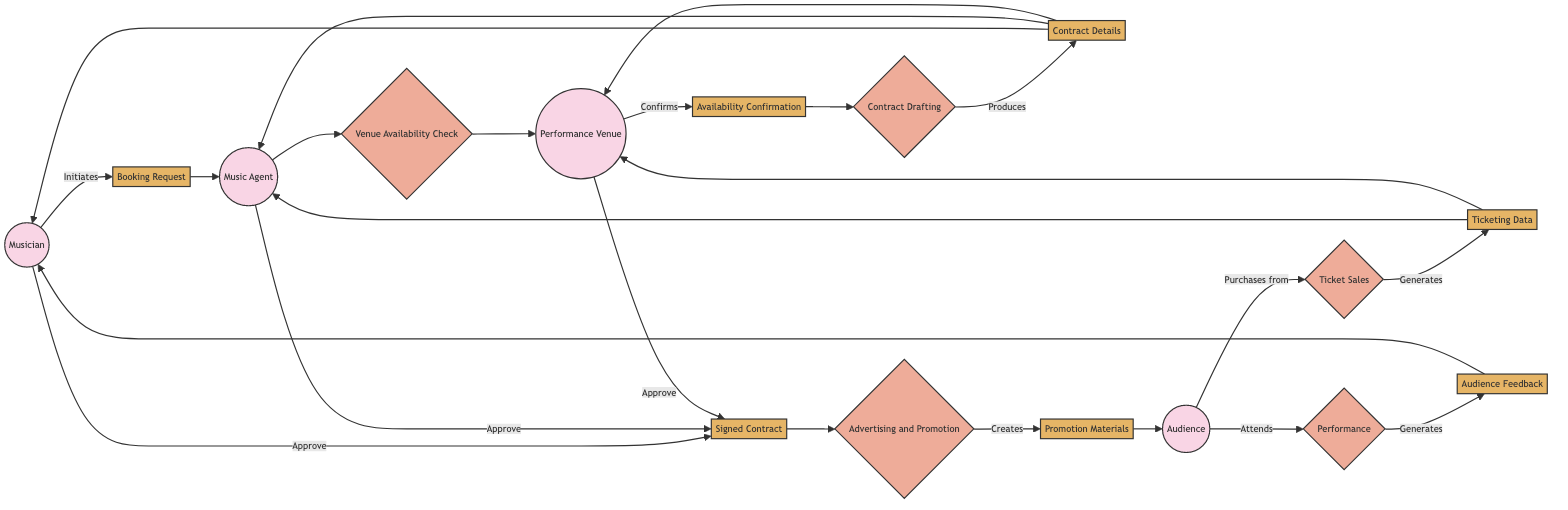What initiates the booking process? The "Musician" is the entity that initiates the booking process by submitting a booking request. This is indicated by the arrow labeled 'Initiates' leading from the Musician to the Booking Request.
Answer: Musician How many external entities are present in the diagram? The diagram shows four external entities: Musician, Music Agent, Performance Venue, and Audience. This can be counted by identifying each labeled external entity in the diagram.
Answer: 4 What is the first data flow in the diagram? The first data flow is the "Booking Request," as it is the initial request submitted by the musician. It is the first flow directed from the Musician towards the Music Agent.
Answer: Booking Request Who confirms the availability of the performance venue? The "Performance Venue" is responsible for confirming the availability, as indicated by the flow from the Performance Venue to the Availability Confirmation node where it states "Confirms."
Answer: Performance Venue What process follows the contract drafting? The process that follows Contract Drafting is "Advertising and Promotion." This is shown as the flow leading from Contract Drafting to Advertising and Promotion in the diagram.
Answer: Advertising and Promotion Which data flow includes information on ticket sales? The data flow that includes information on ticket sales is "Ticketing Data." This flow is generated by the "Ticket Sales" process and is directed towards the Music Agent and Performance Venue.
Answer: Ticketing Data What happens after the audience attends the performance? After the audience attends the performance, "Audience Feedback" is generated, indicating that they provide responses and reviews post-performance. This is denoted in the flow from Performance to Audience Feedback in the diagram.
Answer: Audience Feedback What are the promotion materials related to? The promotion materials are related to "Advertising and Promotion," as they are created during this process to market and promote the concert. This is shown as a product of the Advertising and Promotion process.
Answer: Promotion Materials How do the musician, agent, and venue interact after contract details are created? After the Contract Details are created, the musician, agent, and venue interact by approving the "Signed Contract." This interaction is indicated by the flow where all three entities converge to approve the signed contract.
Answer: Signed Contract 